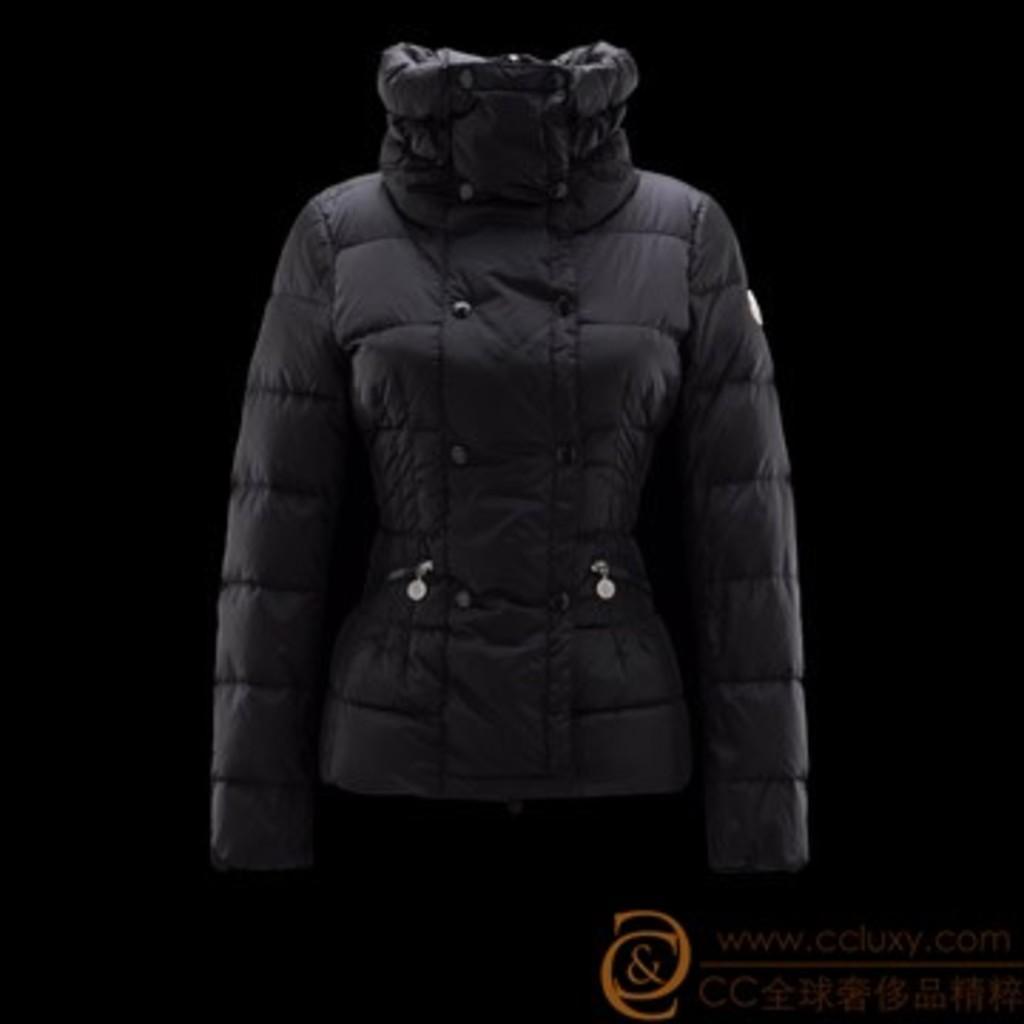In one or two sentences, can you explain what this image depicts? In this image I can see the black color jacket and the background is in black color. 